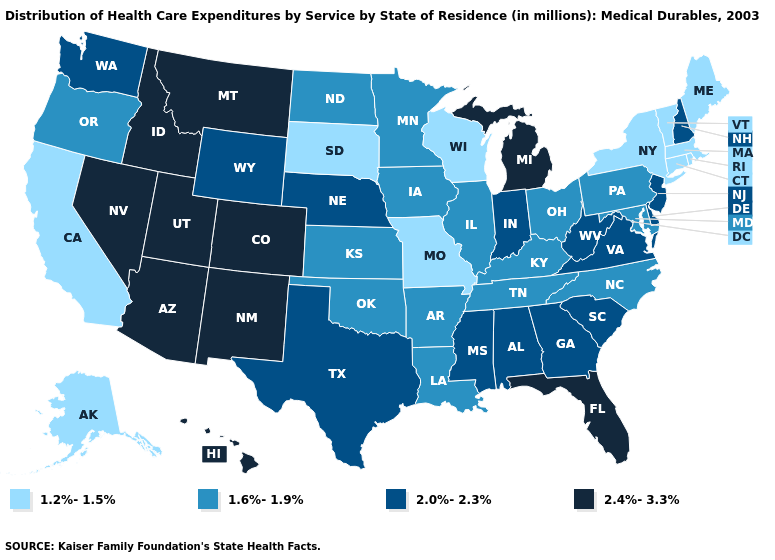Name the states that have a value in the range 2.0%-2.3%?
Give a very brief answer. Alabama, Delaware, Georgia, Indiana, Mississippi, Nebraska, New Hampshire, New Jersey, South Carolina, Texas, Virginia, Washington, West Virginia, Wyoming. Does North Dakota have the lowest value in the USA?
Write a very short answer. No. Name the states that have a value in the range 1.2%-1.5%?
Give a very brief answer. Alaska, California, Connecticut, Maine, Massachusetts, Missouri, New York, Rhode Island, South Dakota, Vermont, Wisconsin. Does Idaho have a higher value than Florida?
Short answer required. No. Name the states that have a value in the range 2.0%-2.3%?
Short answer required. Alabama, Delaware, Georgia, Indiana, Mississippi, Nebraska, New Hampshire, New Jersey, South Carolina, Texas, Virginia, Washington, West Virginia, Wyoming. What is the lowest value in states that border Florida?
Concise answer only. 2.0%-2.3%. What is the value of Mississippi?
Be succinct. 2.0%-2.3%. Name the states that have a value in the range 2.4%-3.3%?
Give a very brief answer. Arizona, Colorado, Florida, Hawaii, Idaho, Michigan, Montana, Nevada, New Mexico, Utah. Does Connecticut have a lower value than Massachusetts?
Be succinct. No. Does the first symbol in the legend represent the smallest category?
Write a very short answer. Yes. Which states have the highest value in the USA?
Be succinct. Arizona, Colorado, Florida, Hawaii, Idaho, Michigan, Montana, Nevada, New Mexico, Utah. Among the states that border Idaho , which have the lowest value?
Keep it brief. Oregon. Does Michigan have a higher value than Utah?
Quick response, please. No. What is the highest value in the MidWest ?
Short answer required. 2.4%-3.3%. Is the legend a continuous bar?
Concise answer only. No. 